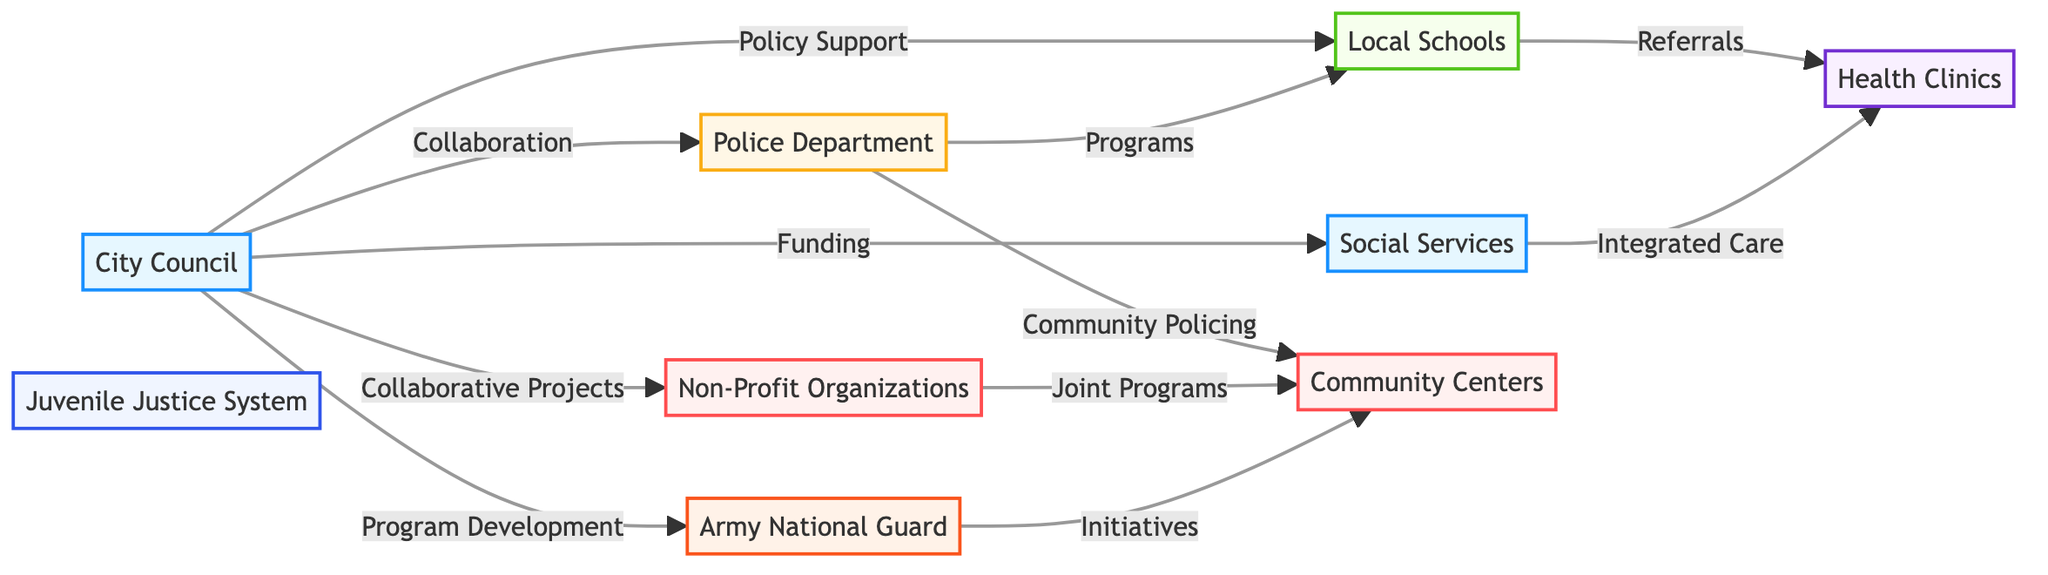What types of organizations are involved in supporting at-risk youth? The diagram includes government bodies, law enforcement, educational institutions, community organizations, healthcare providers, legal entities, and military organizations.
Answer: Government, Law Enforcement, Education, Community, Healthcare, Legal, Military How many entities are connected to the City Council? The City Council is connected to seven different entities in the diagram, each representing a partnership or support relationship.
Answer: Seven What type of relationship exists between the City Council and the Army National Guard? The relationship between the City Council and the Army National Guard is termed "Program Development," indicating a collaborative effort in creating and managing programs for youth.
Answer: Program Development Which organization collaborates with Non-Profit Organizations through joint initiatives? Community Centers work alongside Non-Profit Organizations to execute joint programs focused on supporting at-risk youth.
Answer: Community Centers What service does the Police Department provide to Local Schools? The Police Department provides programs that include school resource officers and anti-bullying initiatives specifically aimed at creating a safer school environment.
Answer: Programs Which two entities work together to provide holistic support to at-risk youth? Social Services and Health Clinics coordinate their efforts to deliver integrated care, ensuring that mental health and family support services are accessible to youth.
Answer: Social Services, Health Clinics What is one of the main focuses of community centers according to the diagram? Community Centers aim to serve as safe spaces that conduct various activities and support groups designed to engage and support youth from the community.
Answer: Safe spaces, activities, support groups How do Local Schools classify their interaction with Health Clinics? Local Schools refer at-risk youth to Health Clinics for appropriate health services, thereby facilitating access to necessary medical and psychological support.
Answer: Referrals What type of program does the Army National Guard implement at Community Centers? The Army National Guard executes community service projects and youth camps at Community Centers to promote leadership and community involvement.
Answer: Initiatives 